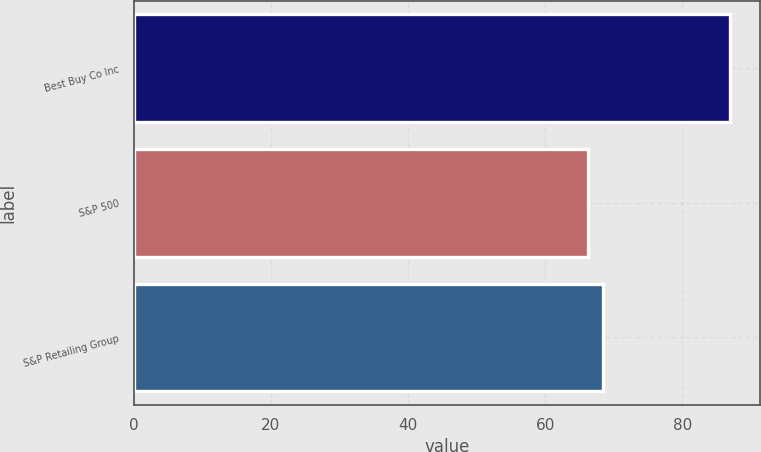Convert chart. <chart><loc_0><loc_0><loc_500><loc_500><bar_chart><fcel>Best Buy Co Inc<fcel>S&P 500<fcel>S&P Retailing Group<nl><fcel>86.96<fcel>66.32<fcel>68.38<nl></chart> 